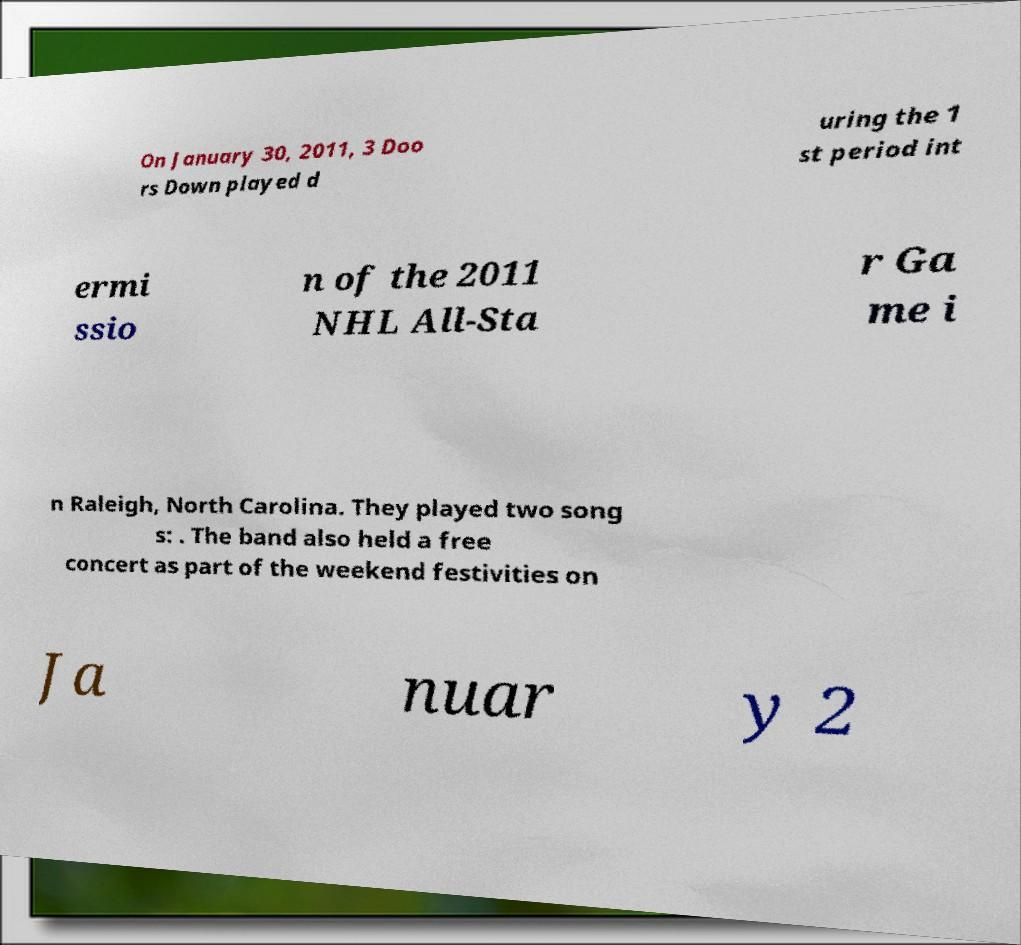Please identify and transcribe the text found in this image. On January 30, 2011, 3 Doo rs Down played d uring the 1 st period int ermi ssio n of the 2011 NHL All-Sta r Ga me i n Raleigh, North Carolina. They played two song s: . The band also held a free concert as part of the weekend festivities on Ja nuar y 2 